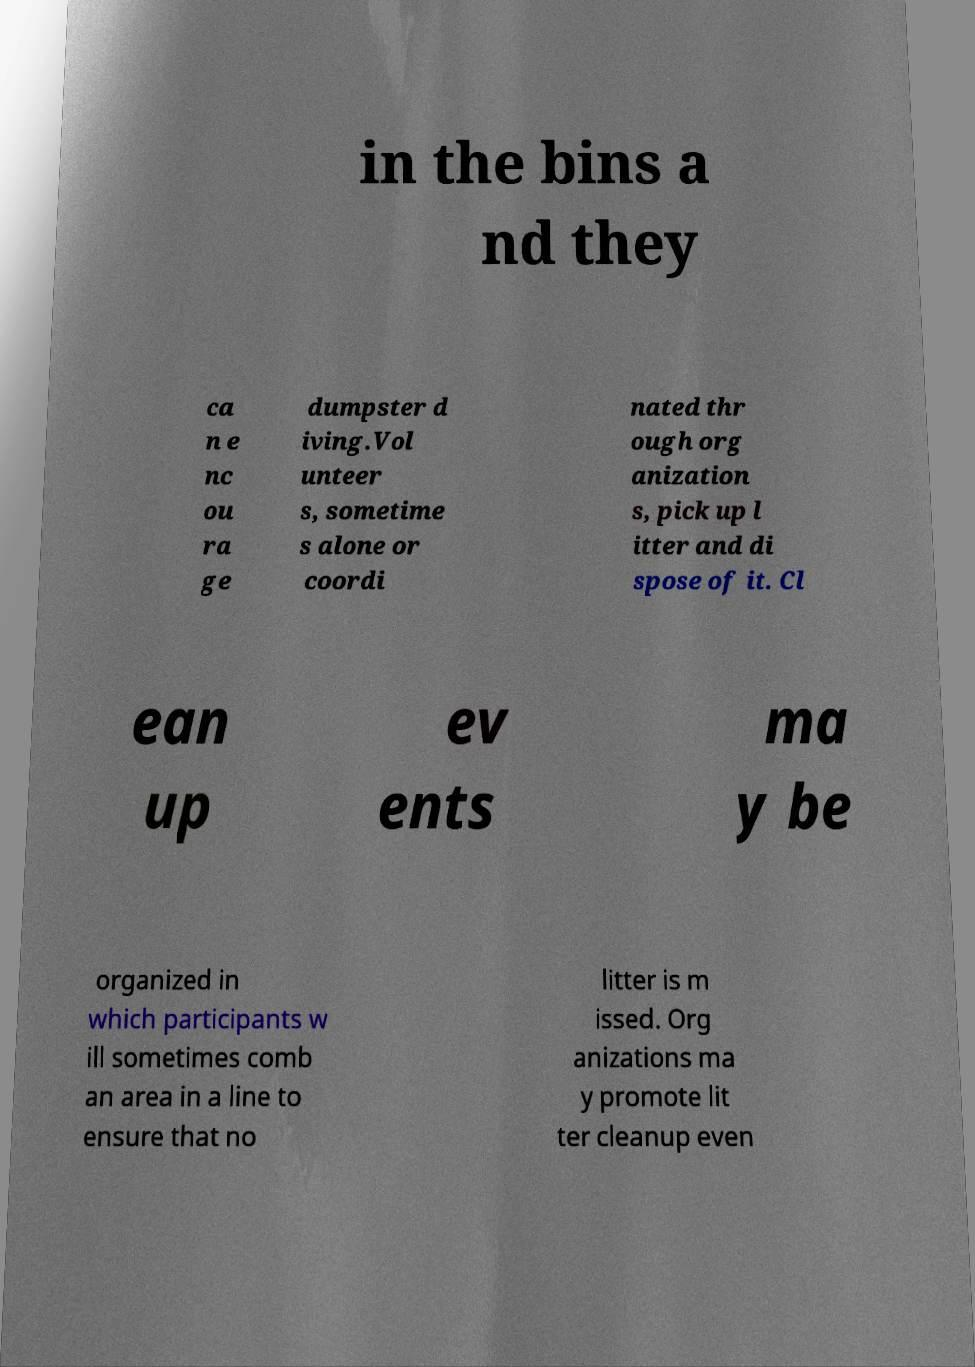Can you read and provide the text displayed in the image?This photo seems to have some interesting text. Can you extract and type it out for me? in the bins a nd they ca n e nc ou ra ge dumpster d iving.Vol unteer s, sometime s alone or coordi nated thr ough org anization s, pick up l itter and di spose of it. Cl ean up ev ents ma y be organized in which participants w ill sometimes comb an area in a line to ensure that no litter is m issed. Org anizations ma y promote lit ter cleanup even 